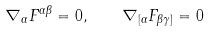<formula> <loc_0><loc_0><loc_500><loc_500>\nabla _ { \alpha } F ^ { \alpha \beta } = 0 , \quad \nabla _ { [ \alpha } F _ { \beta \gamma ] } = 0</formula> 